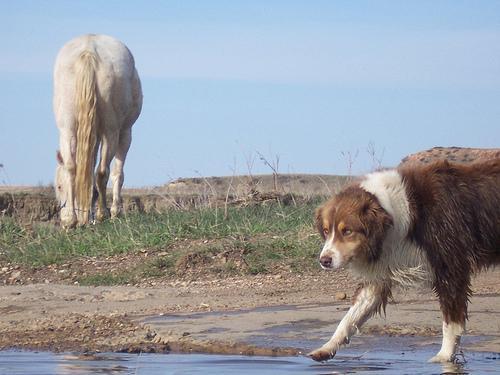How many animals are there?
Give a very brief answer. 2. 